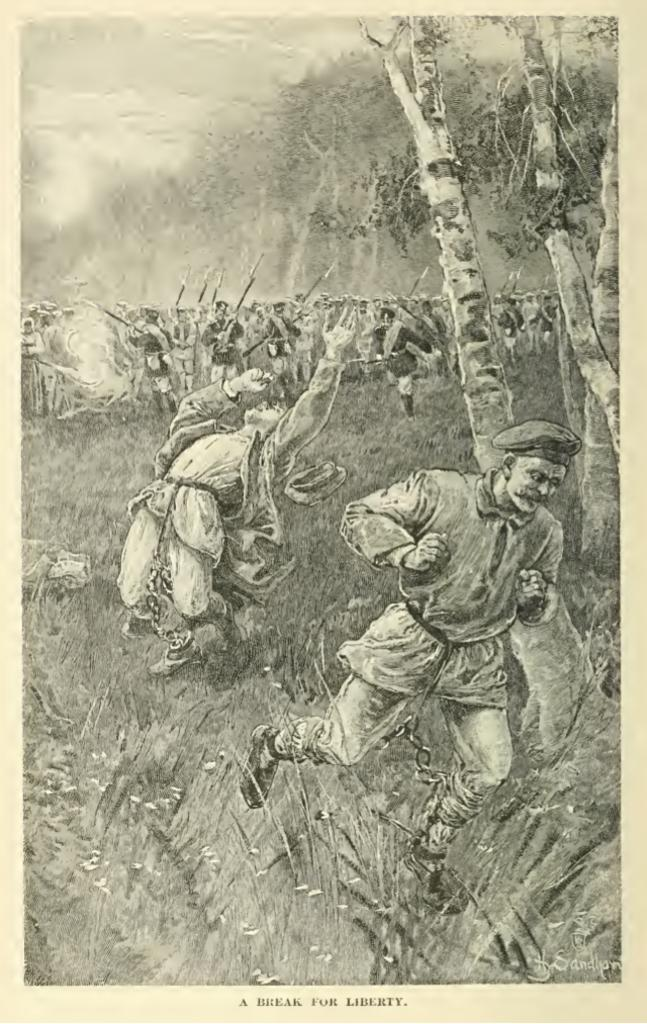<image>
Provide a brief description of the given image. A black and white drawing shows men escaping and is titled a break for liberty. 